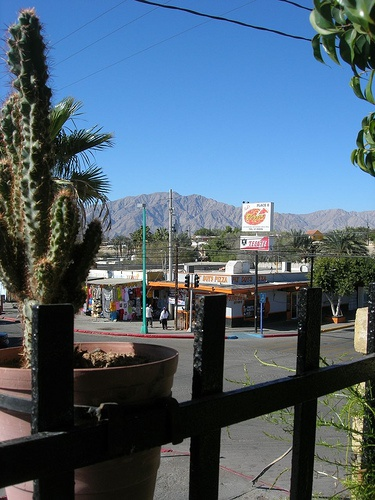Describe the objects in this image and their specific colors. I can see potted plant in gray, black, darkgray, and darkgreen tones, people in gray, black, and darkgray tones, traffic light in gray, black, white, and darkgray tones, people in gray, black, lightgray, and darkgray tones, and people in black, navy, and gray tones in this image. 